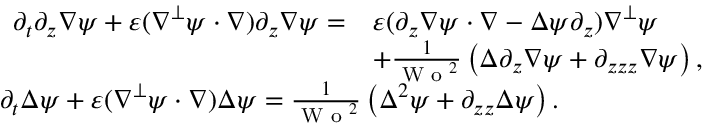<formula> <loc_0><loc_0><loc_500><loc_500>\begin{array} { r l } & { \begin{array} { r l } { \partial _ { t } \partial _ { z } \nabla \psi + \varepsilon ( \nabla ^ { \perp } \psi \cdot \nabla ) \partial _ { z } \nabla \psi = } & { \varepsilon ( \partial _ { z } \nabla \psi \cdot \nabla - \Delta \psi \partial _ { z } ) \nabla ^ { \perp } \psi } \\ & { + \frac { 1 } { W o ^ { 2 } } \left ( \Delta \partial _ { z } \nabla \psi + \partial _ { z z z } \nabla \psi \right ) , } \end{array} } \\ & { \partial _ { t } \Delta \psi + \varepsilon ( \nabla ^ { \perp } \psi \cdot \nabla ) \Delta \psi = \frac { 1 } { W o ^ { 2 } } \left ( \Delta ^ { 2 } \psi + \partial _ { z z } \Delta \psi \right ) . } \end{array}</formula> 